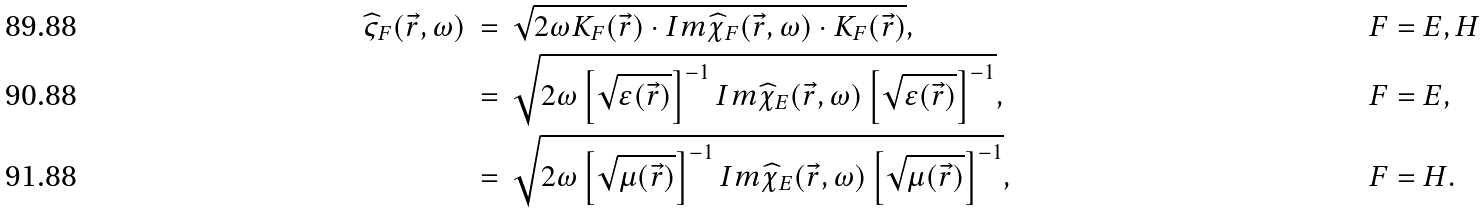Convert formula to latex. <formula><loc_0><loc_0><loc_500><loc_500>\widehat { \varsigma } _ { F } ( \vec { r } , \omega ) \ & = \ \sqrt { 2 \omega K _ { F } ( \vec { r } ) \cdot I m \widehat { \chi } _ { F } ( \vec { r } , \omega ) \cdot K _ { F } ( \vec { r } ) } , & & F = E , H \\ & = \ \sqrt { 2 \omega \left [ \sqrt { \varepsilon ( \vec { r } ) } \right ] ^ { - 1 } I m \widehat { \chi } _ { E } ( \vec { r } , \omega ) \left [ \sqrt { \varepsilon ( \vec { r } ) } \right ] ^ { - 1 } } , & & F = E , \\ & = \ \sqrt { 2 \omega \left [ \sqrt { \mu ( \vec { r } ) } \right ] ^ { - 1 } I m \widehat { \chi } _ { E } ( \vec { r } , \omega ) \left [ \sqrt { \mu ( \vec { r } ) } \right ] ^ { - 1 } } , & & F = H .</formula> 